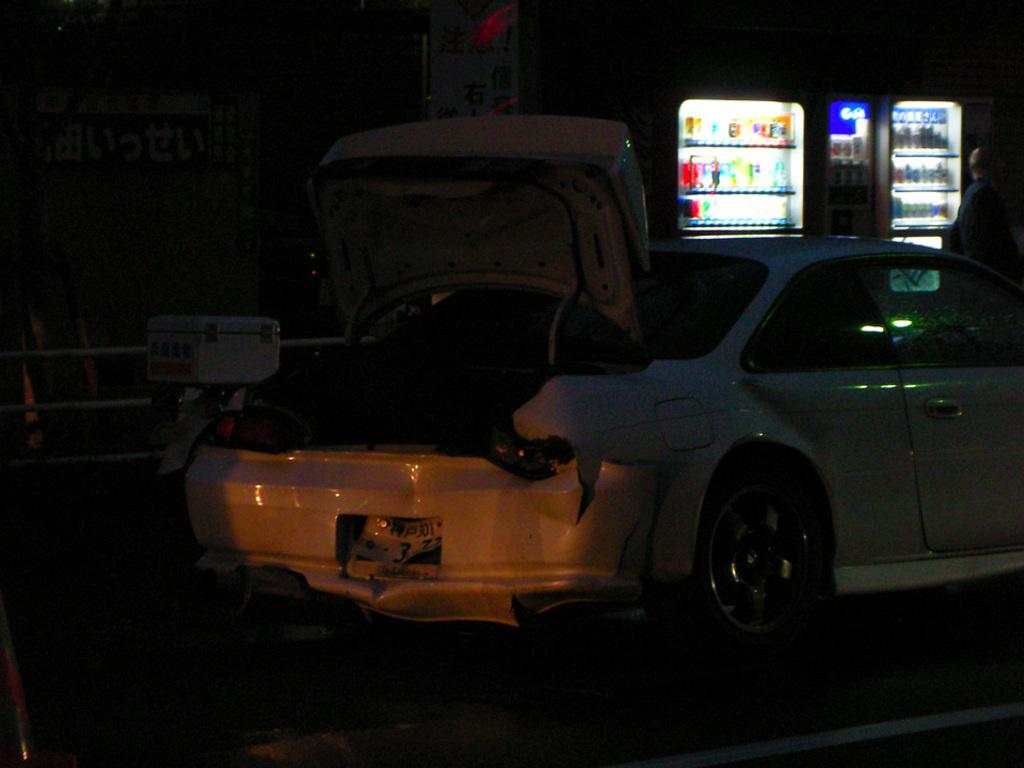What is the condition of the car in the image? There is a half-crushed car on the road in the image. What can be seen in the background of the image? Refrigerators and iron rods are visible in the background. What is inside the refrigerators? Items are present inside the refrigerators. Is there anyone near the refrigerators? Yes, there is a person near the refrigerators. What type of account is being distributed by the person near the refrigerators? There is no mention of an account or distribution in the image; the focus is on the car, refrigerators, and the person near them. 